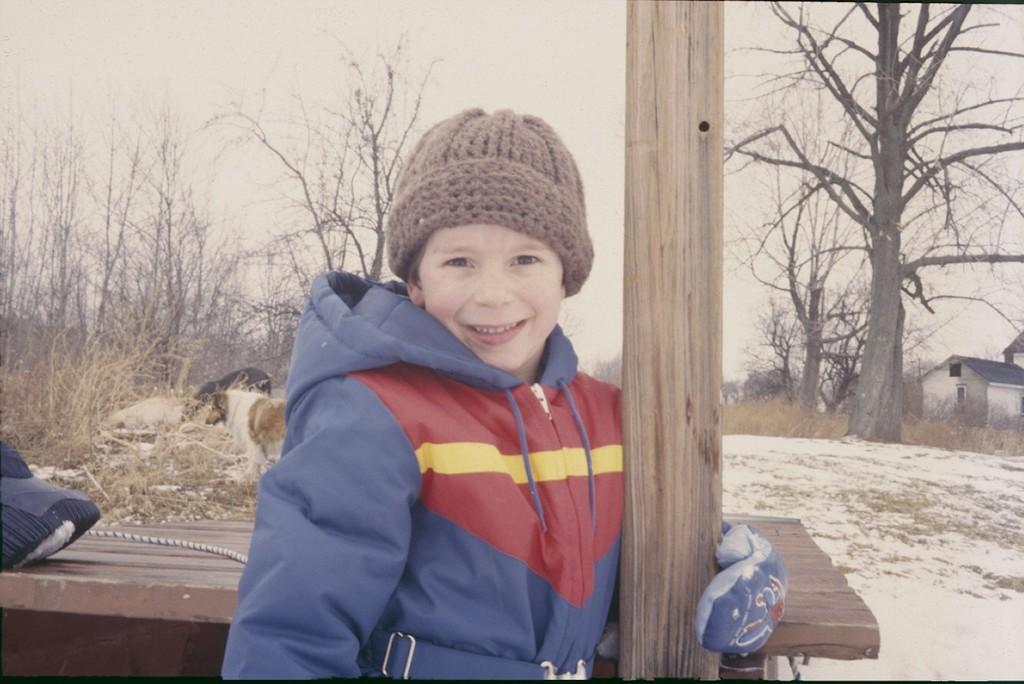Can you describe this image briefly? In the foreground I can see a boy, table and dogs. In the background I can see trees, houses and the sky. This image is taken may be during a day. 